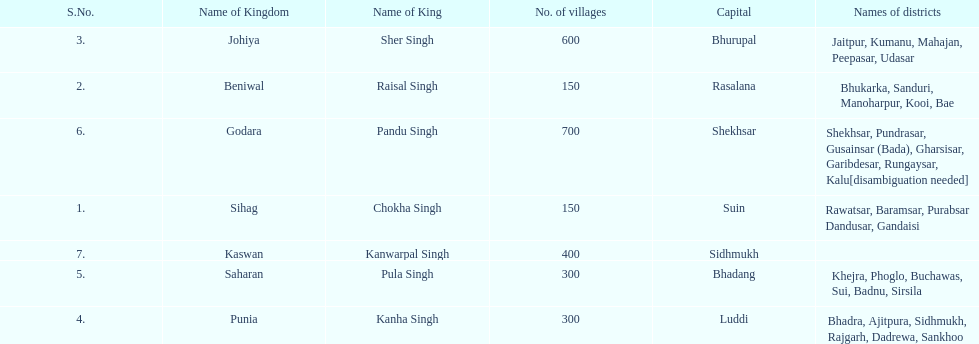Parse the full table. {'header': ['S.No.', 'Name of Kingdom', 'Name of King', 'No. of villages', 'Capital', 'Names of districts'], 'rows': [['3.', 'Johiya', 'Sher Singh', '600', 'Bhurupal', 'Jaitpur, Kumanu, Mahajan, Peepasar, Udasar'], ['2.', 'Beniwal', 'Raisal Singh', '150', 'Rasalana', 'Bhukarka, Sanduri, Manoharpur, Kooi, Bae'], ['6.', 'Godara', 'Pandu Singh', '700', 'Shekhsar', 'Shekhsar, Pundrasar, Gusainsar (Bada), Gharsisar, Garibdesar, Rungaysar, Kalu[disambiguation needed]'], ['1.', 'Sihag', 'Chokha Singh', '150', 'Suin', 'Rawatsar, Baramsar, Purabsar Dandusar, Gandaisi'], ['7.', 'Kaswan', 'Kanwarpal Singh', '400', 'Sidhmukh', ''], ['5.', 'Saharan', 'Pula Singh', '300', 'Bhadang', 'Khejra, Phoglo, Buchawas, Sui, Badnu, Sirsila'], ['4.', 'Punia', 'Kanha Singh', '300', 'Luddi', 'Bhadra, Ajitpura, Sidhmukh, Rajgarh, Dadrewa, Sankhoo']]} What is the next kingdom listed after sihag? Beniwal. 